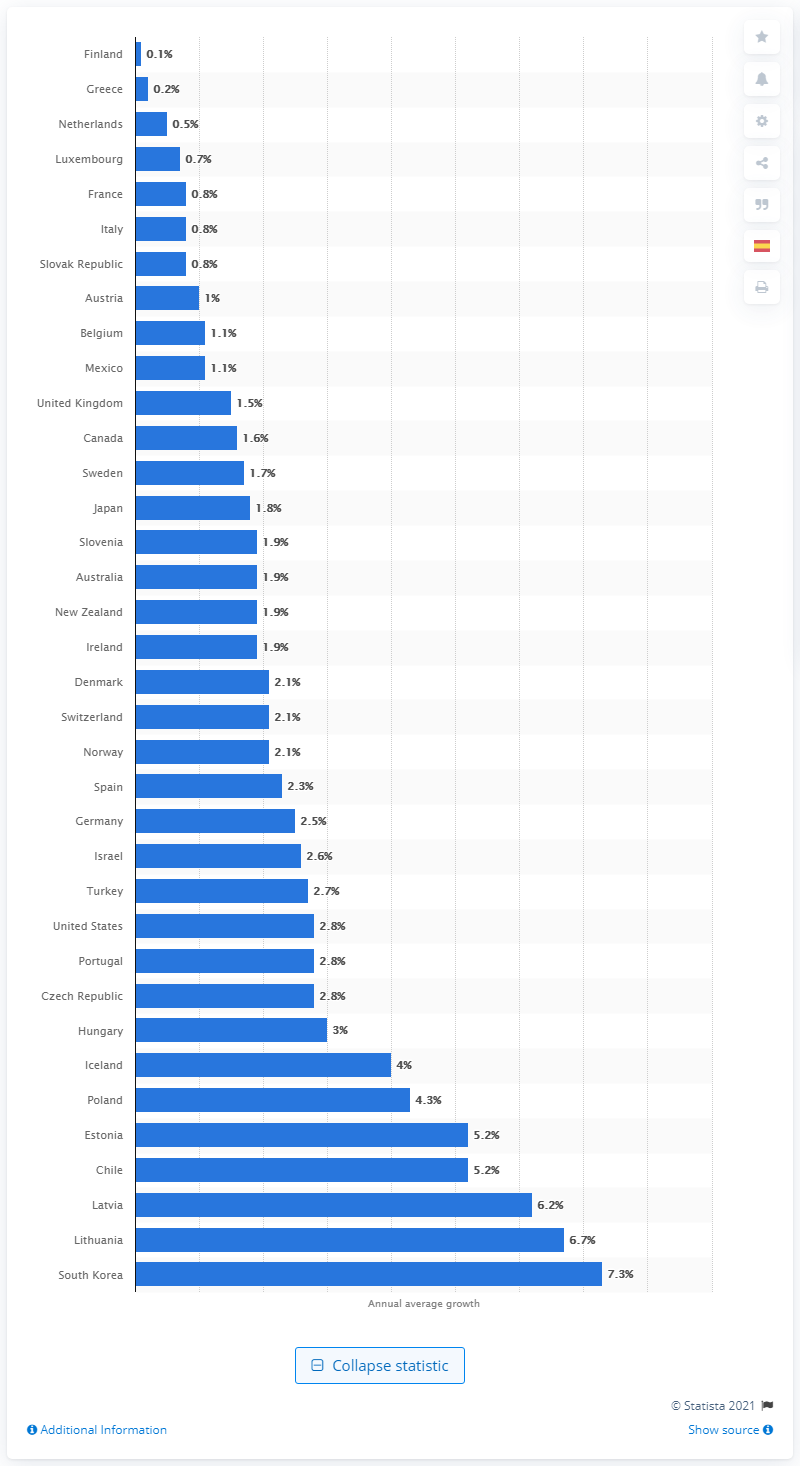Draw attention to some important aspects in this diagram. In Ireland, the average annual increase in per capita health spending was 1.9%. 